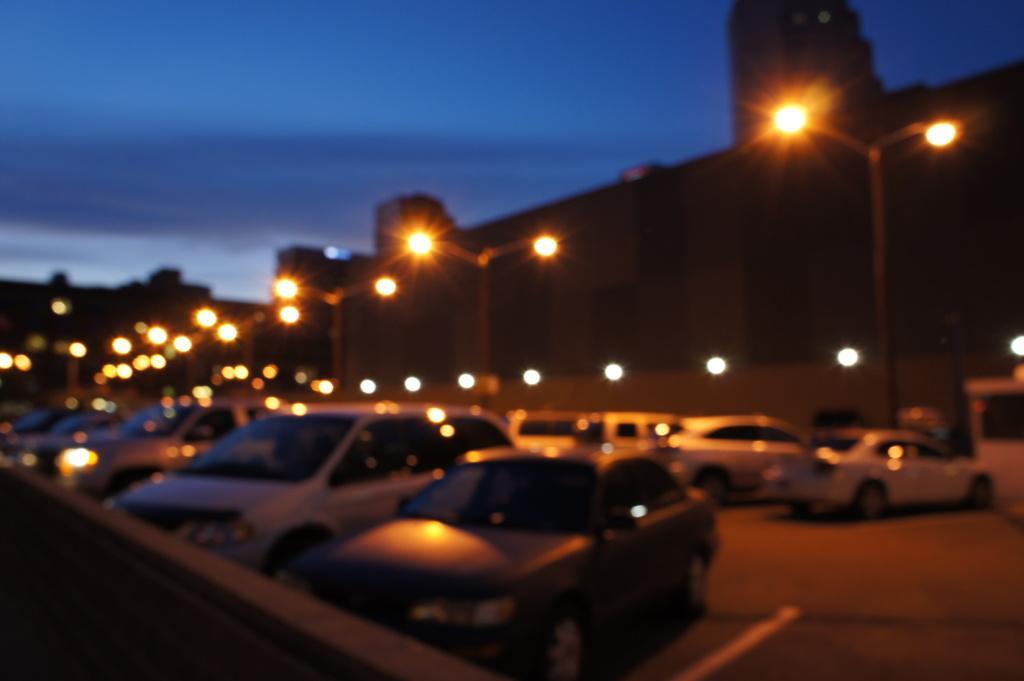Describe this image in one or two sentences. In this picture we can see the buildings, poles, lights, vehicles. In the bottom right corner we can see the road. In the bottom left corner we can see the wall. At the top of the image we can see the clouds in the sky. 